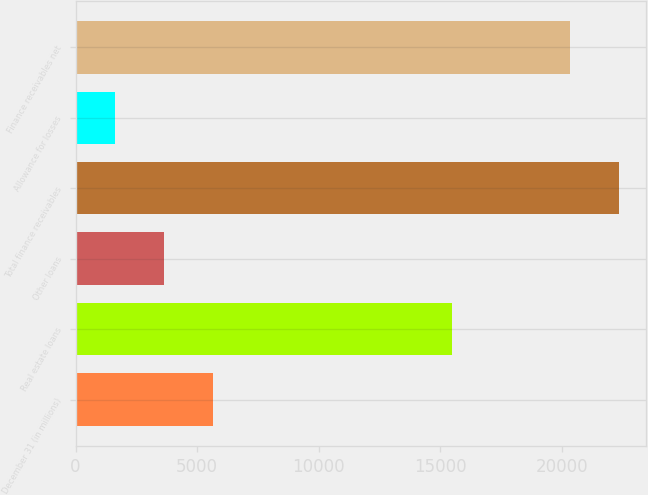<chart> <loc_0><loc_0><loc_500><loc_500><bar_chart><fcel>December 31 (in millions)<fcel>Real estate loans<fcel>Other loans<fcel>Total finance receivables<fcel>Allowance for losses<fcel>Finance receivables net<nl><fcel>5671.4<fcel>15473<fcel>3638.7<fcel>22359.7<fcel>1606<fcel>20327<nl></chart> 